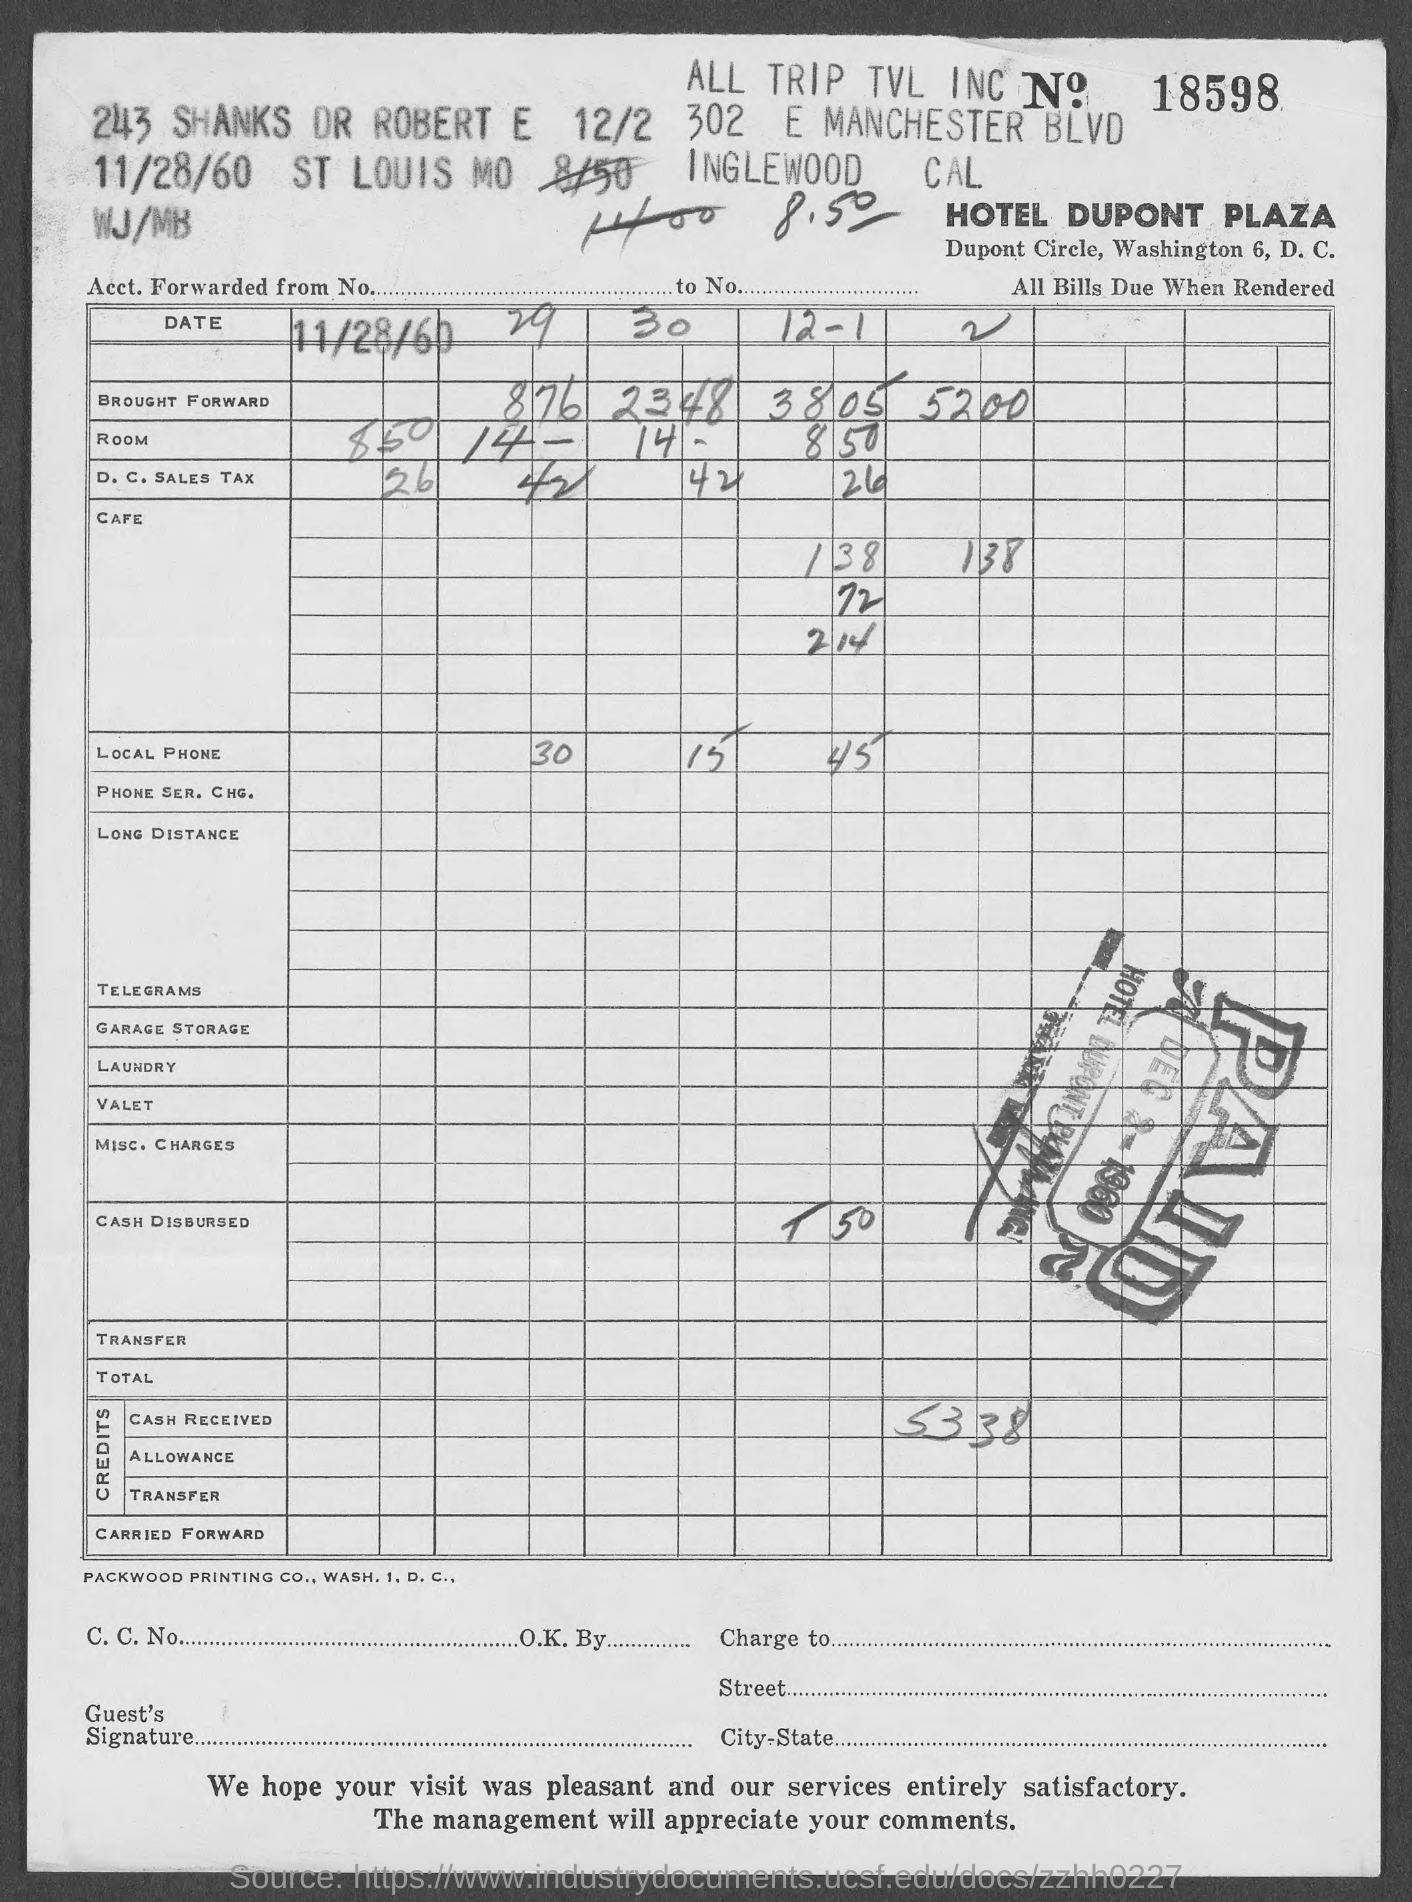Which is the Bill No?
Your answer should be compact. 18598. Which hotel bill is provided?
Keep it short and to the point. HOTEL DUPONT PLAZA. Which is the bill date?
Give a very brief answer. 11/28/60. 